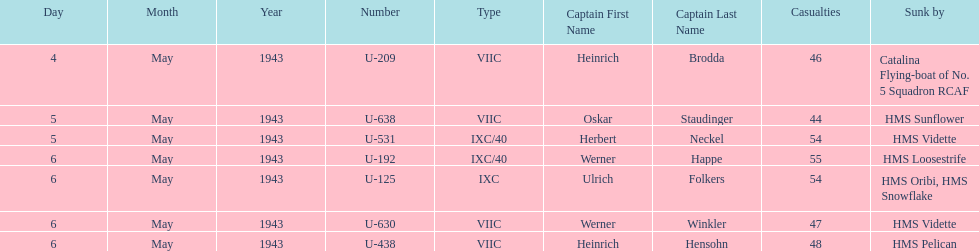Which ship sunk the most u-boats HMS Vidette. 